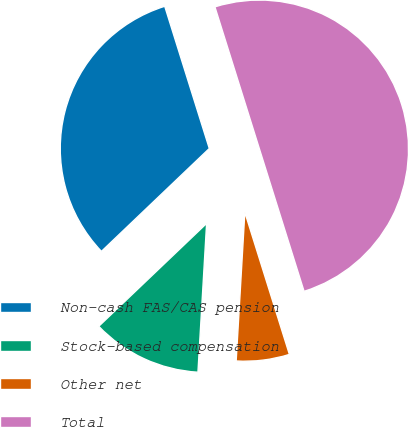Convert chart to OTSL. <chart><loc_0><loc_0><loc_500><loc_500><pie_chart><fcel>Non-cash FAS/CAS pension<fcel>Stock-based compensation<fcel>Other net<fcel>Total<nl><fcel>32.29%<fcel>11.95%<fcel>5.76%<fcel>50.0%<nl></chart> 